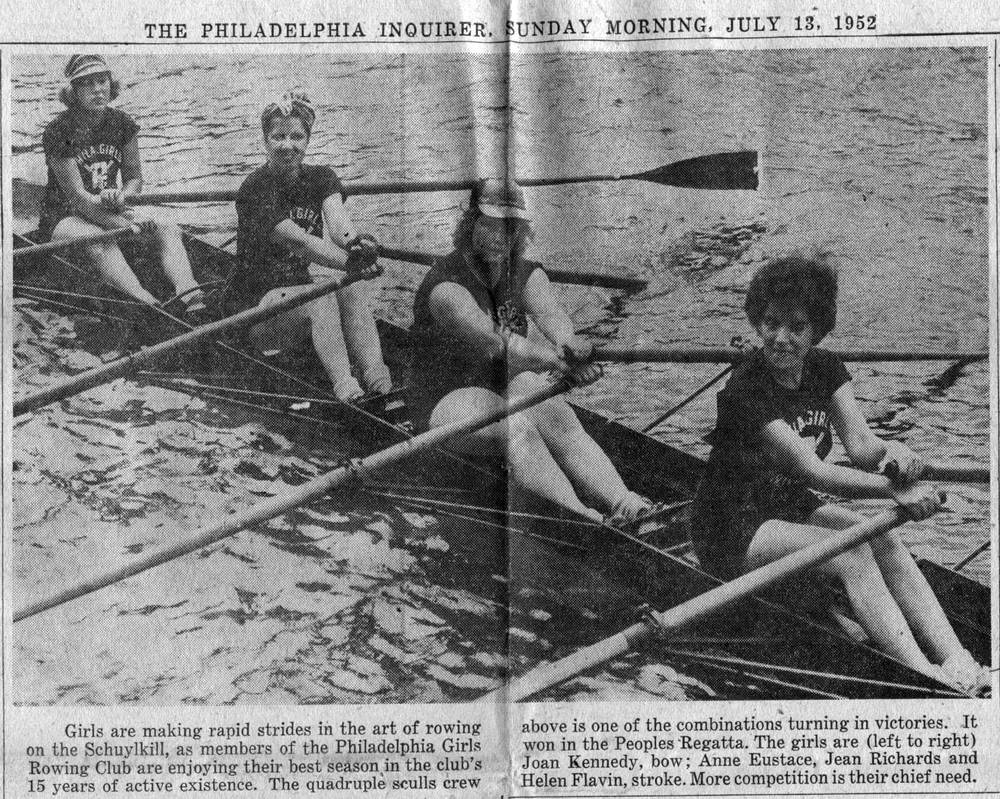Considering the water conditions and the position of the oars, what can be inferred about the speed and stability of the boat? Based on the water conditions and the position of the oars, several inferences can be made. The water around the boat is visibly churned, indicating that the boat is moving at a considerable speed as it cuts through the water. The oars are in various positions, with the first and third rowers' oars lifted out of the water, while the second rower has her oar mid-stroke, which suggests that the photograph captured a moment of transition in their rowing cycle. Despite these different oar positions, there is no significant tilting or unsteadiness visible in the boat's position, implying that the rowers are maintaining stability through synchronized movements and balance. The calm water beyond the immediate vicinity of the churned water suggests that any instability or wake caused by the boat is minimal, further indicating proficient handling and good speed maintenance by the crew. 